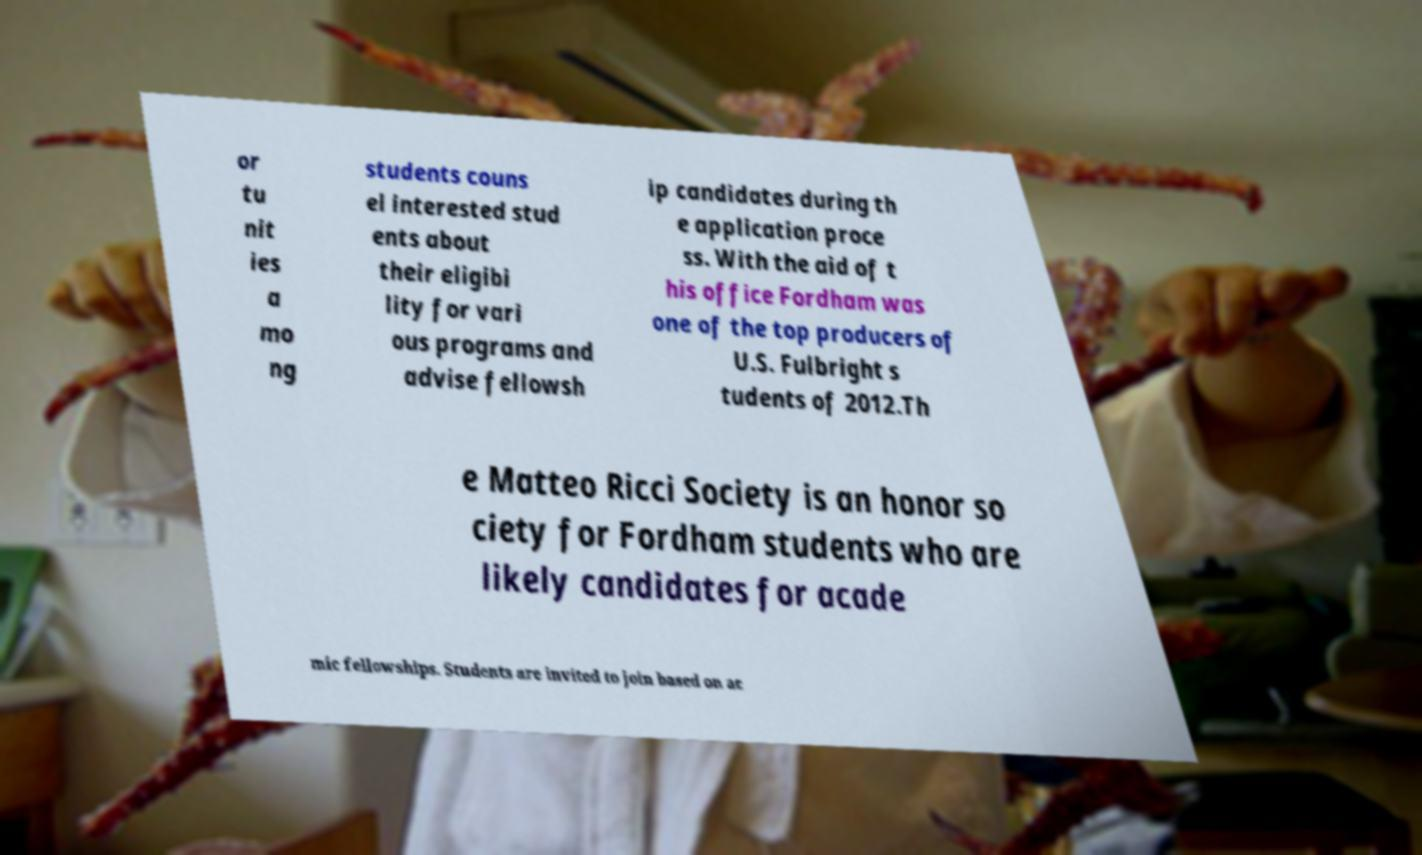Could you extract and type out the text from this image? or tu nit ies a mo ng students couns el interested stud ents about their eligibi lity for vari ous programs and advise fellowsh ip candidates during th e application proce ss. With the aid of t his office Fordham was one of the top producers of U.S. Fulbright s tudents of 2012.Th e Matteo Ricci Society is an honor so ciety for Fordham students who are likely candidates for acade mic fellowships. Students are invited to join based on ac 